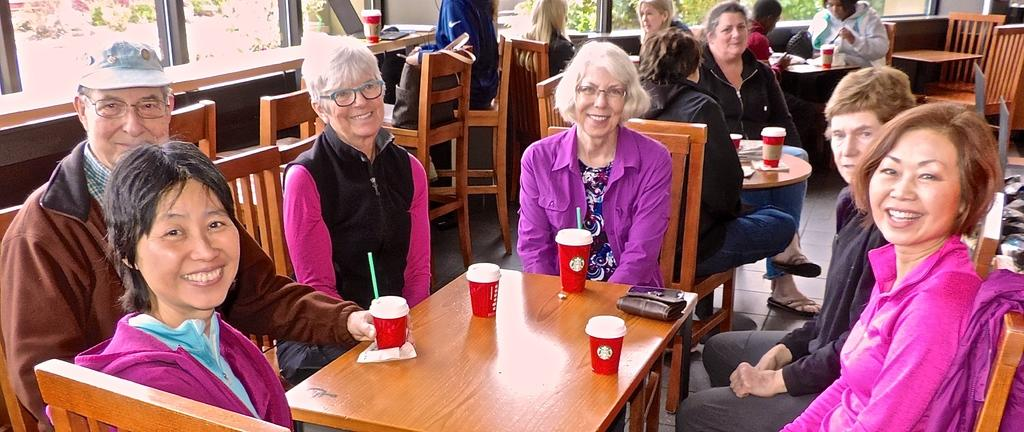What are the people in the image doing? The people in the image are sitting on chairs. What objects can be seen on the tables? There are cups, a laptop, wallets, and mobile phones on the tables. What type of window is present in the image? There is a glass window in the image. What can be seen through the glass window? Trees are visible through the glass window. On which floor is the scene taking place? The scene is on a floor. What type of quicksand can be seen in the image? There is no quicksand present in the image. What color is the crayon used to draw on the building in the image? There is no building or crayon present in the image. 